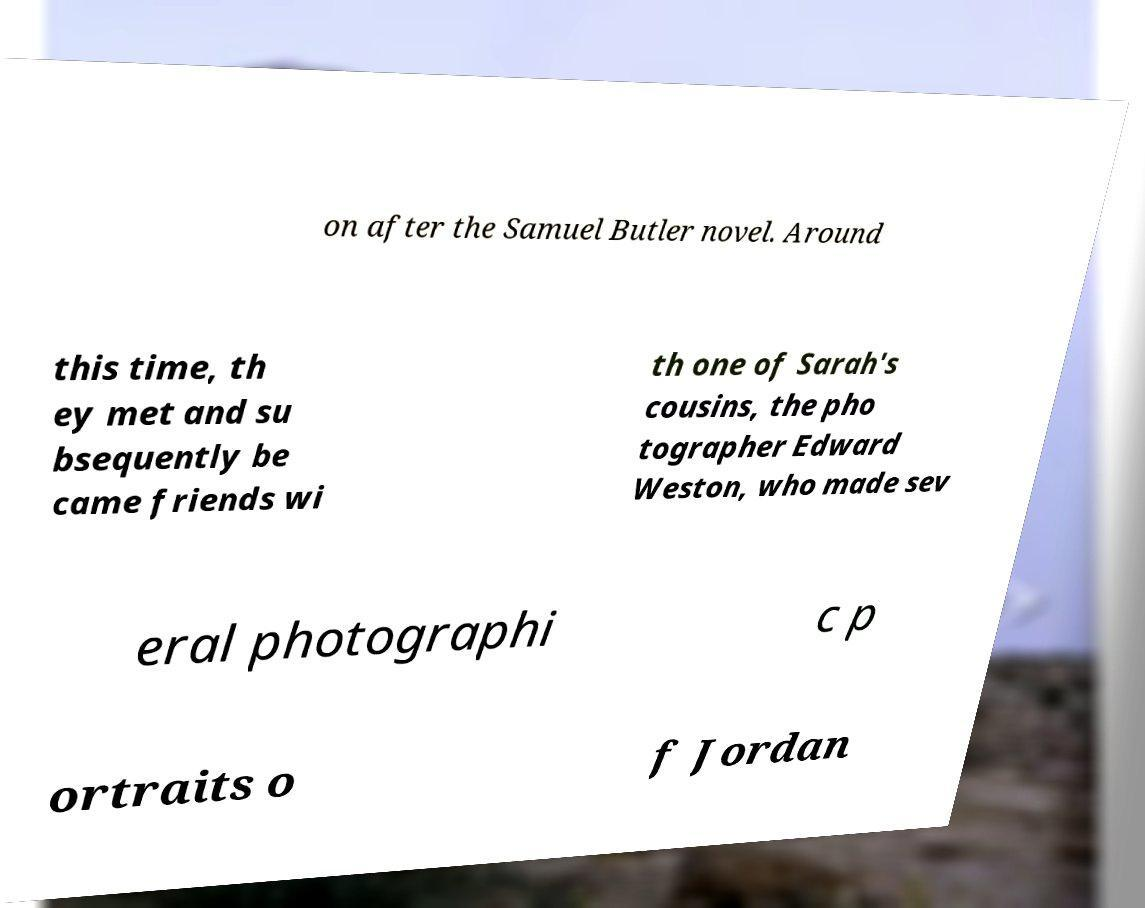For documentation purposes, I need the text within this image transcribed. Could you provide that? on after the Samuel Butler novel. Around this time, th ey met and su bsequently be came friends wi th one of Sarah's cousins, the pho tographer Edward Weston, who made sev eral photographi c p ortraits o f Jordan 